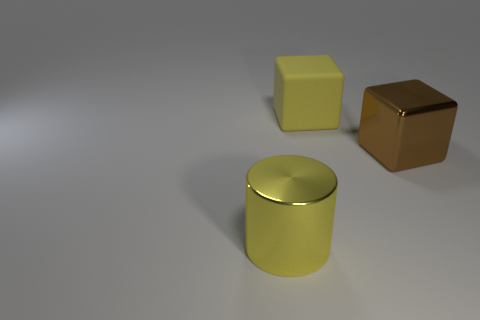How do the shadows in the image inform us about the light source? The shadows in the image are cast diagonally towards the bottom right, indicating that the light source is positioned towards the top left of the image, likely out of frame. The shadows are soft-edged, suggesting a diffused light source rather than a point light, contributing to the gentle illumination of the objects. 